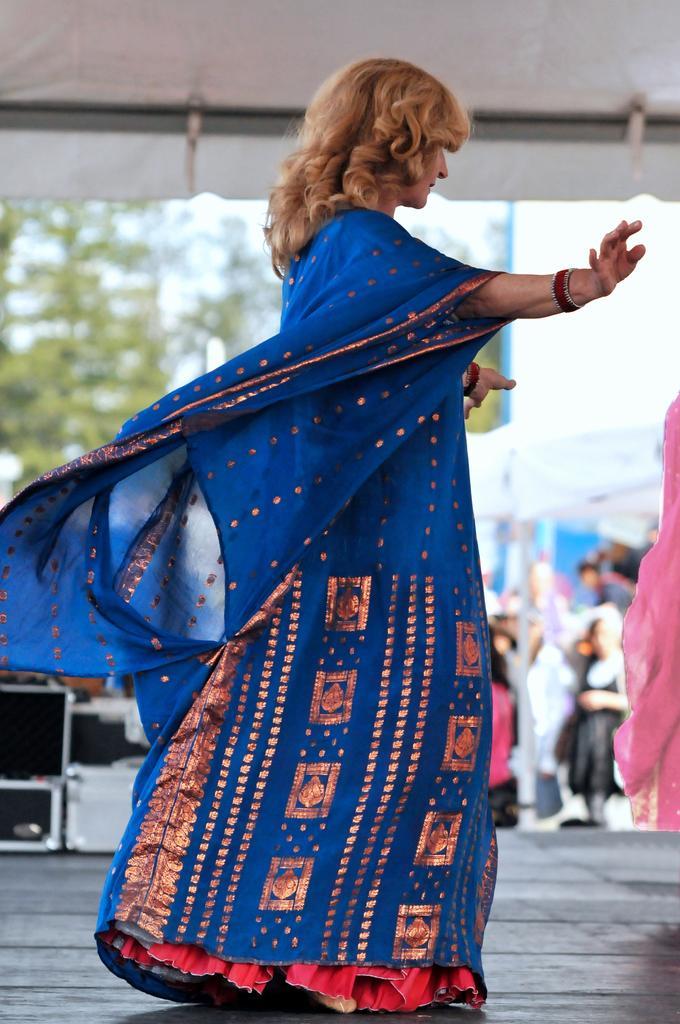Could you give a brief overview of what you see in this image? In this picture there is a lady in the center of the image and there are boxes in the background area of the image and there are people, stalls, and trees in the background area of the image and there is another lady on the right side of the image. 